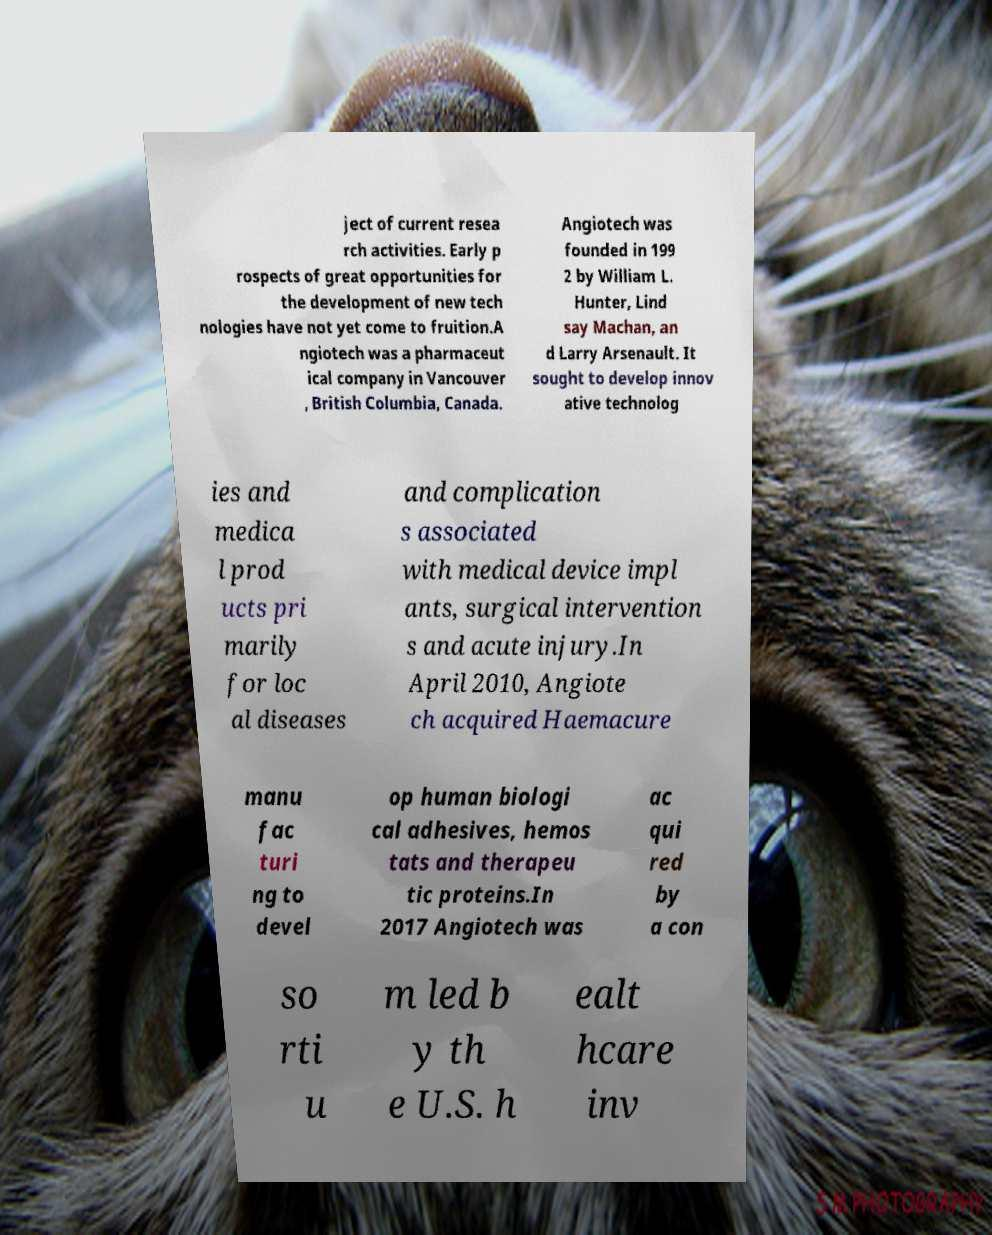For documentation purposes, I need the text within this image transcribed. Could you provide that? ject of current resea rch activities. Early p rospects of great opportunities for the development of new tech nologies have not yet come to fruition.A ngiotech was a pharmaceut ical company in Vancouver , British Columbia, Canada. Angiotech was founded in 199 2 by William L. Hunter, Lind say Machan, an d Larry Arsenault. It sought to develop innov ative technolog ies and medica l prod ucts pri marily for loc al diseases and complication s associated with medical device impl ants, surgical intervention s and acute injury.In April 2010, Angiote ch acquired Haemacure manu fac turi ng to devel op human biologi cal adhesives, hemos tats and therapeu tic proteins.In 2017 Angiotech was ac qui red by a con so rti u m led b y th e U.S. h ealt hcare inv 